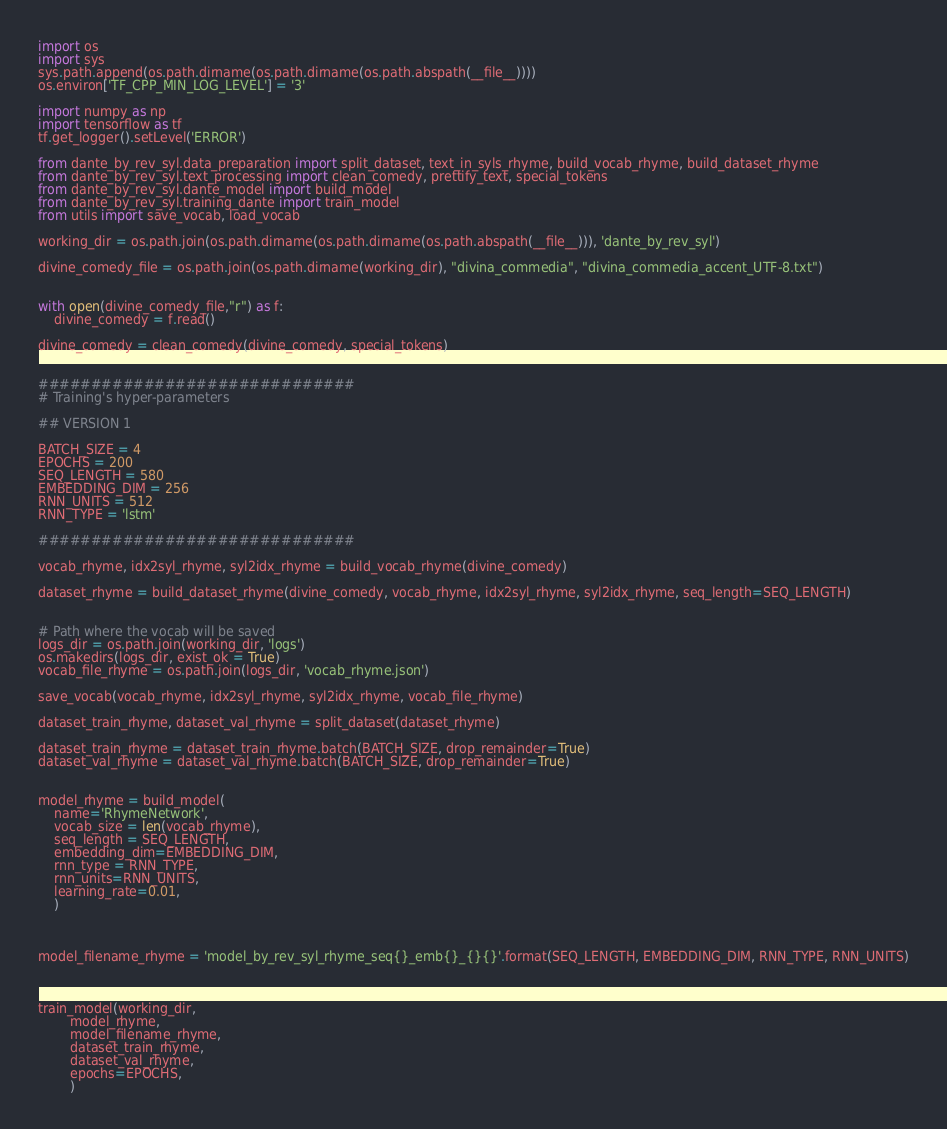<code> <loc_0><loc_0><loc_500><loc_500><_Python_>import os
import sys
sys.path.append(os.path.dirname(os.path.dirname(os.path.abspath(__file__))))
os.environ['TF_CPP_MIN_LOG_LEVEL'] = '3'

import numpy as np
import tensorflow as tf
tf.get_logger().setLevel('ERROR')

from dante_by_rev_syl.data_preparation import split_dataset, text_in_syls_rhyme, build_vocab_rhyme, build_dataset_rhyme
from dante_by_rev_syl.text_processing import clean_comedy, prettify_text, special_tokens
from dante_by_rev_syl.dante_model import build_model
from dante_by_rev_syl.training_dante import train_model
from utils import save_vocab, load_vocab

working_dir = os.path.join(os.path.dirname(os.path.dirname(os.path.abspath(__file__))), 'dante_by_rev_syl')

divine_comedy_file = os.path.join(os.path.dirname(working_dir), "divina_commedia", "divina_commedia_accent_UTF-8.txt") 


with open(divine_comedy_file,"r") as f:
    divine_comedy = f.read()

divine_comedy = clean_comedy(divine_comedy, special_tokens)


##############################
# Training's hyper-parameters

## VERSION 1

BATCH_SIZE = 4
EPOCHS = 200
SEQ_LENGTH = 580
EMBEDDING_DIM = 256
RNN_UNITS = 512
RNN_TYPE = 'lstm'

##############################

vocab_rhyme, idx2syl_rhyme, syl2idx_rhyme = build_vocab_rhyme(divine_comedy)

dataset_rhyme = build_dataset_rhyme(divine_comedy, vocab_rhyme, idx2syl_rhyme, syl2idx_rhyme, seq_length=SEQ_LENGTH)


# Path where the vocab will be saved
logs_dir = os.path.join(working_dir, 'logs')
os.makedirs(logs_dir, exist_ok = True) 
vocab_file_rhyme = os.path.join(logs_dir, 'vocab_rhyme.json')

save_vocab(vocab_rhyme, idx2syl_rhyme, syl2idx_rhyme, vocab_file_rhyme)

dataset_train_rhyme, dataset_val_rhyme = split_dataset(dataset_rhyme)

dataset_train_rhyme = dataset_train_rhyme.batch(BATCH_SIZE, drop_remainder=True)
dataset_val_rhyme = dataset_val_rhyme.batch(BATCH_SIZE, drop_remainder=True)


model_rhyme = build_model(
    name='RhymeNetwork',
    vocab_size = len(vocab_rhyme),
    seq_length = SEQ_LENGTH,
    embedding_dim=EMBEDDING_DIM,
    rnn_type = RNN_TYPE,
    rnn_units=RNN_UNITS,
    learning_rate=0.01,
    )



model_filename_rhyme = 'model_by_rev_syl_rhyme_seq{}_emb{}_{}{}'.format(SEQ_LENGTH, EMBEDDING_DIM, RNN_TYPE, RNN_UNITS)



train_model(working_dir, 
        model_rhyme,
        model_filename_rhyme,
        dataset_train_rhyme, 
        dataset_val_rhyme, 
        epochs=EPOCHS, 
        )



</code> 